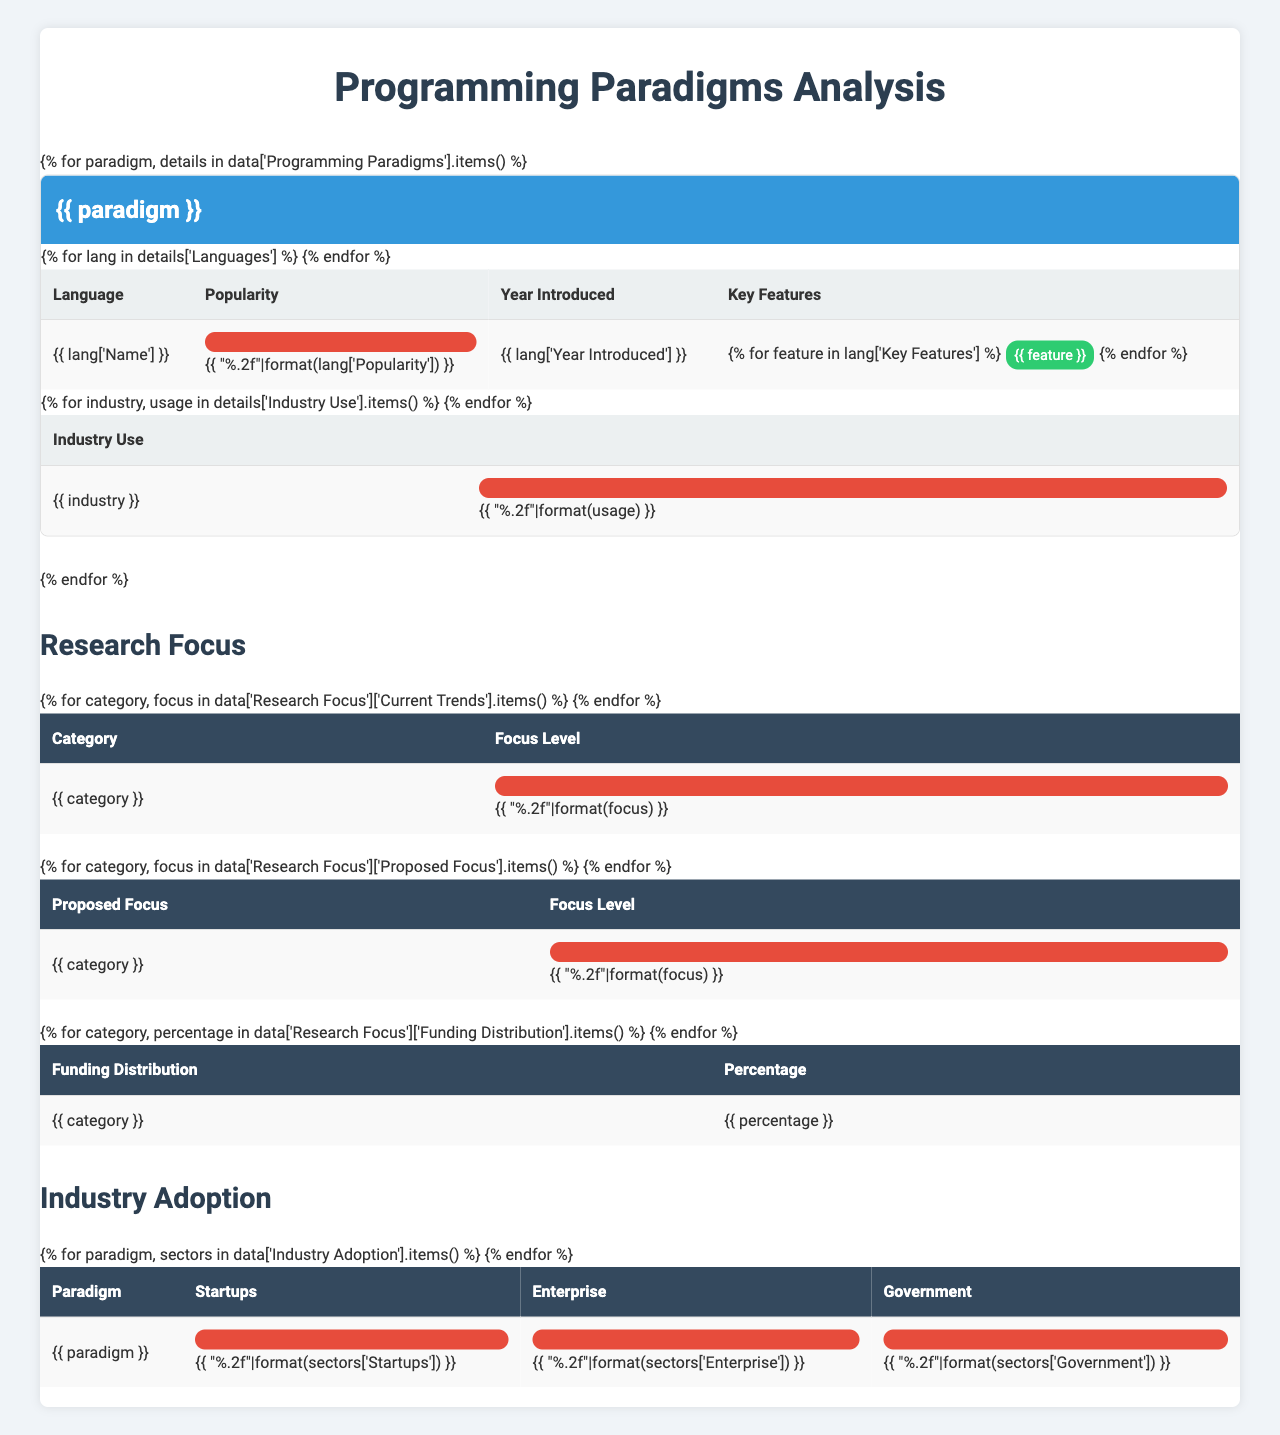What is the most popular object-oriented programming language listed? The table shows the popularity of each language under the object-oriented programming paradigm. Java has the highest popularity at 0.95, followed by Python at 0.92 and C++ at 0.85.
Answer: Java List the key features of Clojure. Clojure, a functional programming language, has its key features listed as a LISP dialect, concurrent programming, and macros according to the table.
Answer: LISP dialect, concurrent programming, macros Which programming paradigm has the lowest popularity rating? By examining the table, Logic Programming has the lowest popularity rating with Prolog at 0.25 and Mercury at 0.1.
Answer: Logic Programming What are the total industry use percentages for functional programming in Data Analysis and Artificial Intelligence? The table indicates that the industry use for functional programming in Data Analysis is 0.7 and in Artificial Intelligence is 0.65. Adding these together gives us 0.7 + 0.65 = 1.35.
Answer: 1.35 Is Python used in game development according to the data? The table shows the industry use for Object-Oriented Programming in Game Development is 0.65, but it does not specify whether Python is specifically used, as it highlights overall trends instead.
Answer: No What is the average industry use for Logic Programming across the given sectors? The industry use for Logic Programming in Artificial Intelligence is 0.4, in Natural Language Processing is 0.35, and in Expert Systems is 0.3. Adding these together gives 0.4 + 0.35 + 0.3 = 1.05, and dividing by 3 (the number of sectors) gives an average of 1.05 / 3 = 0.35.
Answer: 0.35 Which paradigm has the highest adoption among startups? The table lists the industry adoption rates for paradigms among startups, showing Object-Oriented Programming at 0.8, Functional Programming at 0.6, and Logic Programming at 0.2. Therefore, Object-Oriented Programming has the highest adoption.
Answer: Object-Oriented Programming How many programming languages in the Object-Oriented Programming paradigm were introduced after 1990? The table indicates that Java was introduced in 1995, Python in 1991, and C++ in 1979. Therefore, the languages introduced after 1990 are Java and Python, totaling 2.
Answer: 2 Is there any language listed with a popularity rating below 0.3? The table indicates that the lowest popularity rating is for Mercury at 0.1, which is below 0.3, confirming that there is indeed at least one language with a rating lower than 0.3.
Answer: Yes What percentage of funding is allocated to Machine Learning? The funding distribution table shows that Machine Learning receives 45% of the funding, making it a significant focus area currently.
Answer: 45% 